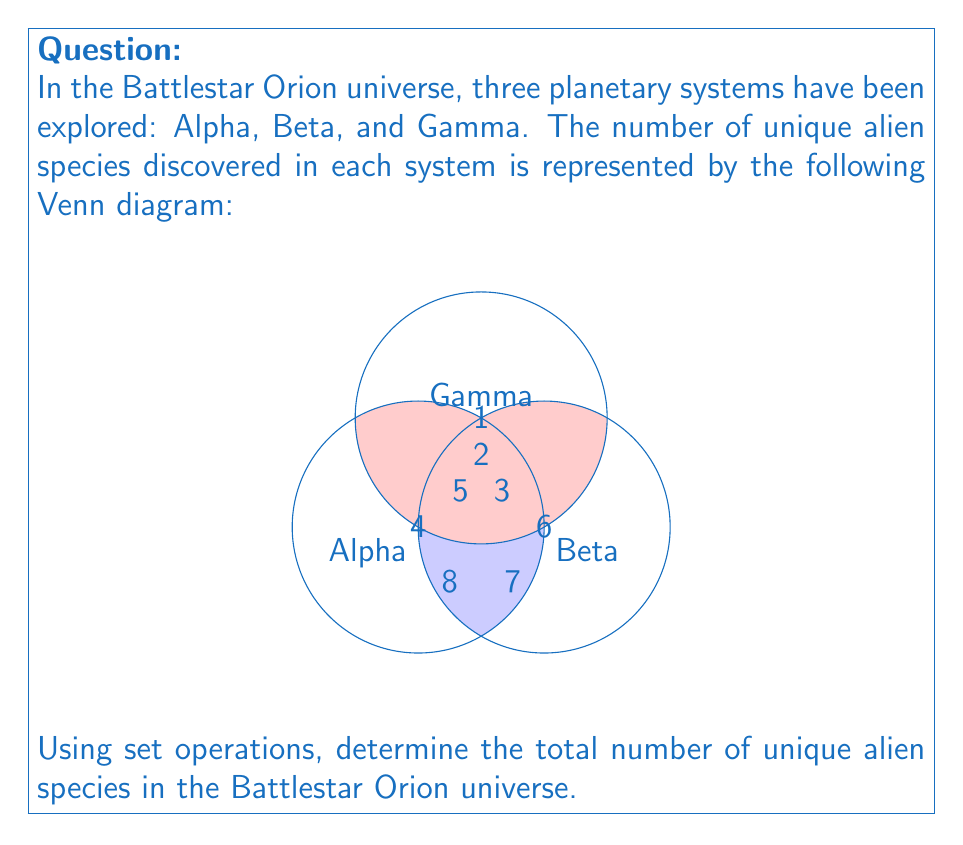Solve this math problem. Let's approach this step-by-step using set theory:

1) Let A, B, and C represent the sets of alien species in Alpha, Beta, and Gamma systems respectively.

2) We need to find $|A \cup B \cup C|$, which represents the total number of unique alien species.

3) We can use the Inclusion-Exclusion Principle:

   $$|A \cup B \cup C| = |A| + |B| + |C| - |A \cap B| - |A \cap C| - |B \cap C| + |A \cap B \cap C|$$

4) From the Venn diagram:
   - $|A| = 4 + 5 + 8 + 2 = 19$
   - $|B| = 6 + 5 + 7 + 3 = 21$
   - $|C| = 1 + 2 + 3 + 2 = 8$
   - $|A \cap B| = 5$
   - $|A \cap C| = 2$
   - $|B \cap C| = 3$
   - $|A \cap B \cap C| = 2$

5) Substituting these values into the formula:

   $$|A \cup B \cup C| = 19 + 21 + 8 - 5 - 2 - 3 + 2 = 40$$

Therefore, there are 40 unique alien species in the Battlestar Orion universe.
Answer: 40 unique alien species 